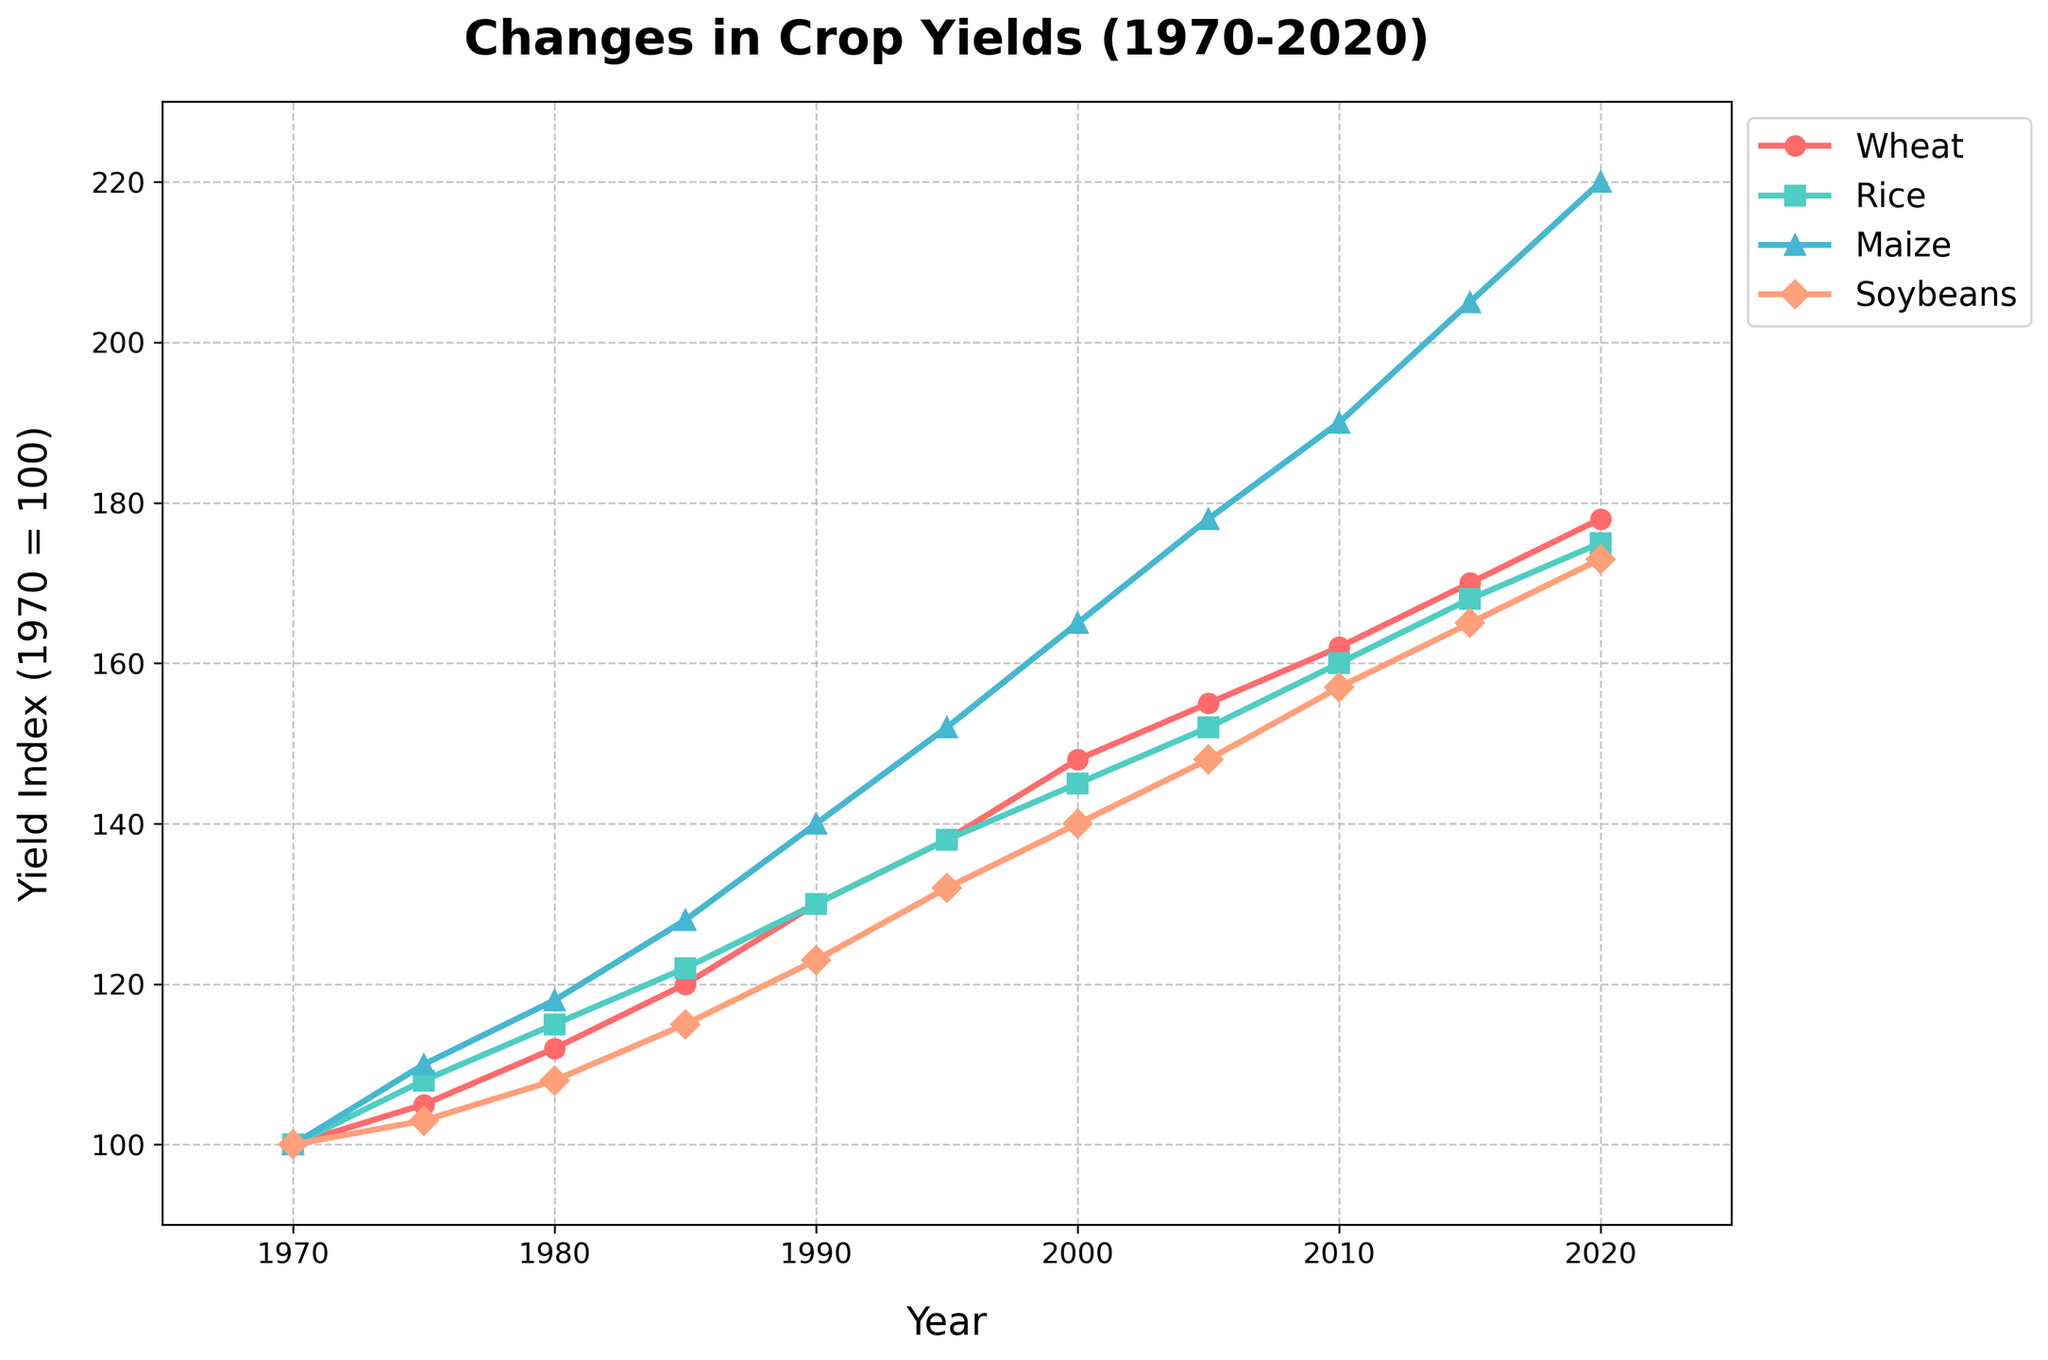Which crop had the highest yield index in 2020? First, we locate the year 2020 on the x-axis. Then, we compare the y-values (yield index) of all four crops. The crop with the highest y-value corresponds to the highest yield index. In 2020, the maize line is the highest on the chart.
Answer: Maize Compare the yield index of rice and wheat in 1985. Which one was higher and by how much? Locate 1985 on the x-axis and check the y-values for rice and wheat. Rice has a yield index of 122 and wheat has a yield index of 120. Subtract wheat's index from rice's index: 122 - 120 = 2.
Answer: Rice, by 2 What was the overall increase in the yield index of soybeans from 1970 to 2020? Determine the yield index of soybeans in 1970 and 2020. In 1970, the index is 100 and in 2020 it is 173. Calculate the difference: 173 - 100 = 73.
Answer: 73 Which period saw the greatest average increase in wheat yield per year: 1970-1980 or 2010-2020? Calculate the increase in wheat yield from 1970 to 1980 and from 2010 to 2020. For 1970-1980: 112 - 100 = 12 over 10 years, average = 12/10 = 1.2 per year. For 2010-2020: 178 - 162 = 16 over 10 years, average = 16/10 = 1.6 per year.
Answer: 2010-2020 What is the color and marker type used to represent maize in the chart? Observe the lines and legend that correspond to maize. The maize yield index line uses blue with triangle markers.
Answer: Blue, triangle Between which consecutive decades did rice see the smallest increase in yield index? Compare the increase in the yield index of rice for each decade: 1970-1980, 108-100=8; 1980-1990, 130-115=15; 1990-2000, 145-130=15; 2000-2010, 160-145=15; 2010-2020, 175-160=15. The smallest increase was from 1970 to 1980.
Answer: 1970-1980 What is the trend in the yield index of soybeans from 2000 to 2015, and does it show a consistent pattern of increase? Observe the soybean yield index from 2000 to 2015: it increases from 140 to 165. The trend is consistently upward without any drop.
Answer: Yes, consistent increase By how much did the yield index of wheat and maize differ in 1995? Locate 1995 on the x-axis and compare the yield index of wheat (138) and maize (152). Subtract wheat's index from maize's: 152 - 138 = 14.
Answer: 14 